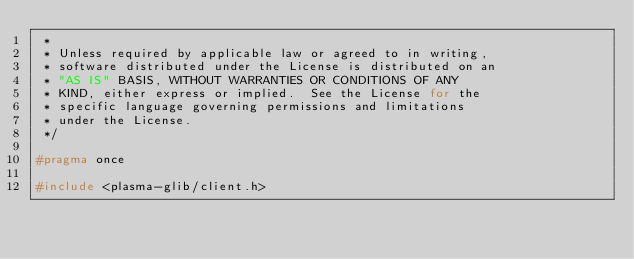<code> <loc_0><loc_0><loc_500><loc_500><_C_> *
 * Unless required by applicable law or agreed to in writing,
 * software distributed under the License is distributed on an
 * "AS IS" BASIS, WITHOUT WARRANTIES OR CONDITIONS OF ANY
 * KIND, either express or implied.  See the License for the
 * specific language governing permissions and limitations
 * under the License.
 */

#pragma once

#include <plasma-glib/client.h>
</code> 